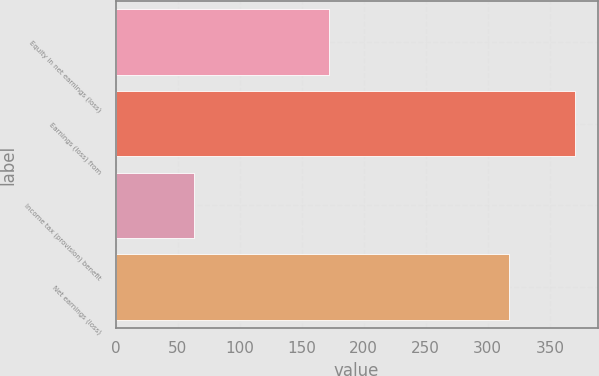Convert chart to OTSL. <chart><loc_0><loc_0><loc_500><loc_500><bar_chart><fcel>Equity in net earnings (loss)<fcel>Earnings (loss) from<fcel>Income tax (provision) benefit<fcel>Net earnings (loss)<nl><fcel>172<fcel>370<fcel>63<fcel>317<nl></chart> 